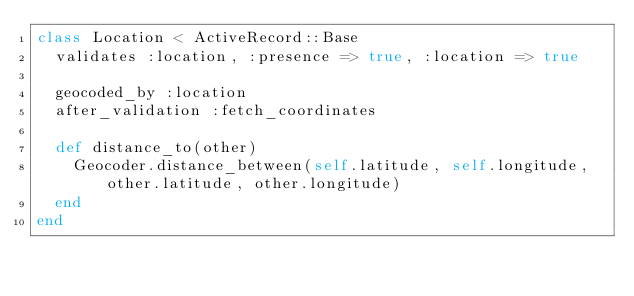<code> <loc_0><loc_0><loc_500><loc_500><_Ruby_>class Location < ActiveRecord::Base
  validates :location, :presence => true, :location => true

  geocoded_by :location
  after_validation :fetch_coordinates

  def distance_to(other)
    Geocoder.distance_between(self.latitude, self.longitude, other.latitude, other.longitude)
  end
end
</code> 